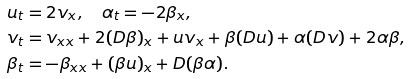Convert formula to latex. <formula><loc_0><loc_0><loc_500><loc_500>u _ { t } & = 2 v _ { x } , \quad \alpha _ { t } = - 2 \beta _ { x } , \\ v _ { t } & = v _ { x x } + 2 ( D \beta ) _ { x } + u v _ { x } + \beta ( D u ) + \alpha ( D v ) + 2 \alpha \beta , \\ \beta _ { t } & = - \beta _ { x x } + ( \beta u ) _ { x } + D ( \beta \alpha ) .</formula> 